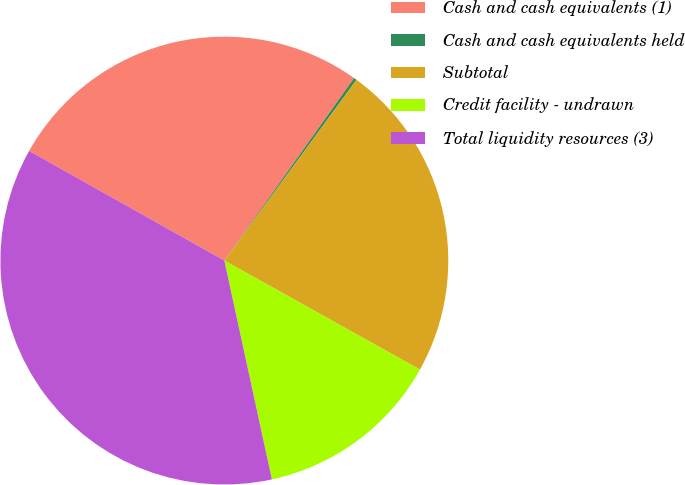Convert chart. <chart><loc_0><loc_0><loc_500><loc_500><pie_chart><fcel>Cash and cash equivalents (1)<fcel>Cash and cash equivalents held<fcel>Subtotal<fcel>Credit facility - undrawn<fcel>Total liquidity resources (3)<nl><fcel>26.69%<fcel>0.21%<fcel>23.05%<fcel>13.5%<fcel>36.55%<nl></chart> 